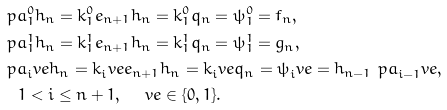<formula> <loc_0><loc_0><loc_500><loc_500>& \ p a _ { 1 } ^ { 0 } h _ { n } = k _ { 1 } ^ { 0 } e _ { n + 1 } h _ { n } = k _ { 1 } ^ { 0 } q _ { n } = \psi _ { 1 } ^ { 0 } = f _ { n } , \\ & \ p a _ { 1 } ^ { 1 } h _ { n } = k _ { 1 } ^ { 1 } e _ { n + 1 } h _ { n } = k _ { 1 } ^ { 1 } q _ { n } = \psi _ { 1 } ^ { 1 } = g _ { n } , \\ & \ p a _ { i } ^ { \ } v e h _ { n } = k _ { i } ^ { \ } v e e _ { n + 1 } h _ { n } = k _ { i } ^ { \ } v e q _ { n } = \psi _ { i } ^ { \ } v e = h _ { n - 1 } \ p a _ { i - 1 } ^ { \ } v e , \\ & \quad 1 < i \leq n + 1 , \quad \ v e \in \{ 0 , 1 \} .</formula> 